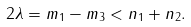<formula> <loc_0><loc_0><loc_500><loc_500>2 \lambda = m _ { 1 } - m _ { 3 } < n _ { 1 } + n _ { 2 } .</formula> 